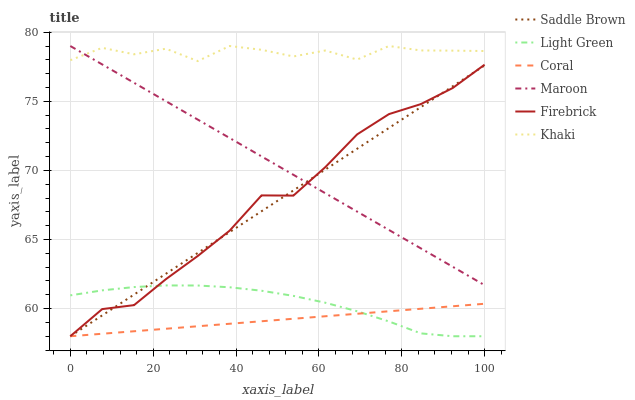Does Maroon have the minimum area under the curve?
Answer yes or no. No. Does Maroon have the maximum area under the curve?
Answer yes or no. No. Is Coral the smoothest?
Answer yes or no. No. Is Coral the roughest?
Answer yes or no. No. Does Maroon have the lowest value?
Answer yes or no. No. Does Coral have the highest value?
Answer yes or no. No. Is Coral less than Khaki?
Answer yes or no. Yes. Is Khaki greater than Coral?
Answer yes or no. Yes. Does Coral intersect Khaki?
Answer yes or no. No. 